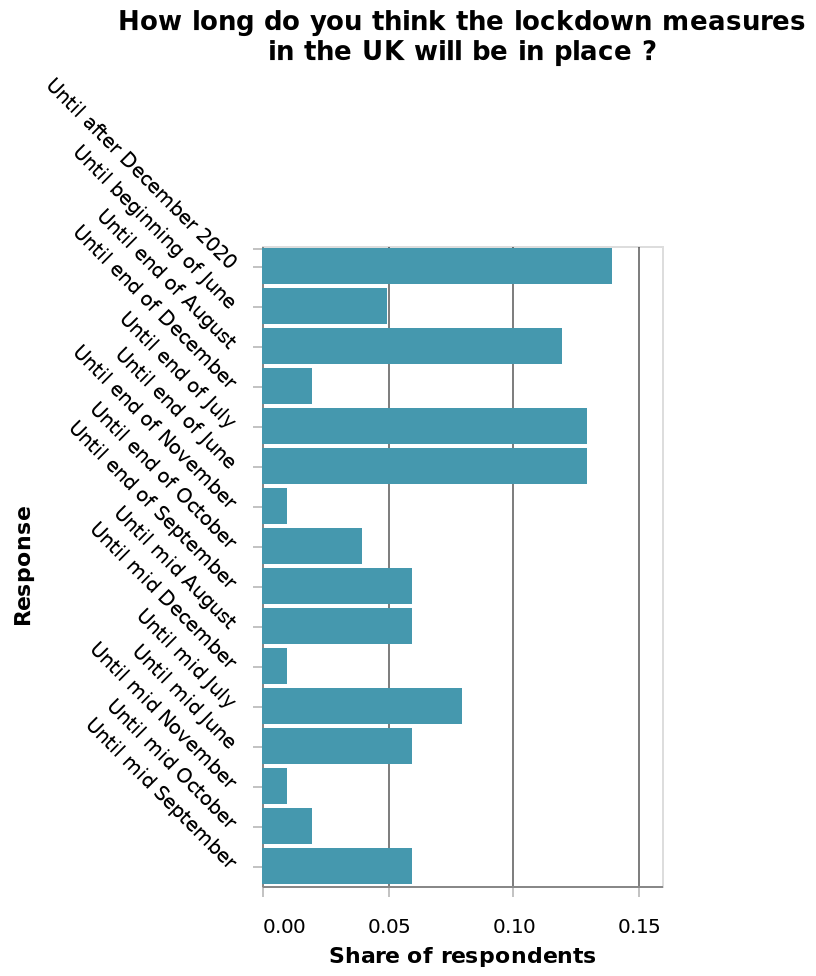<image>
What information does the bar plot provide? The bar plot provides data on the duration of the lockdown measures in the UK based on the responses of the respondents. What is the label of the bar plot?  The bar plot is labeled as "How long do you think the lockdown measures in the UK will be in place?". Did the majority of respondents believe that the lockdown would be lifted before December 2020?  No, most respondents believed that the lockdown would be in place until after December 2020. 